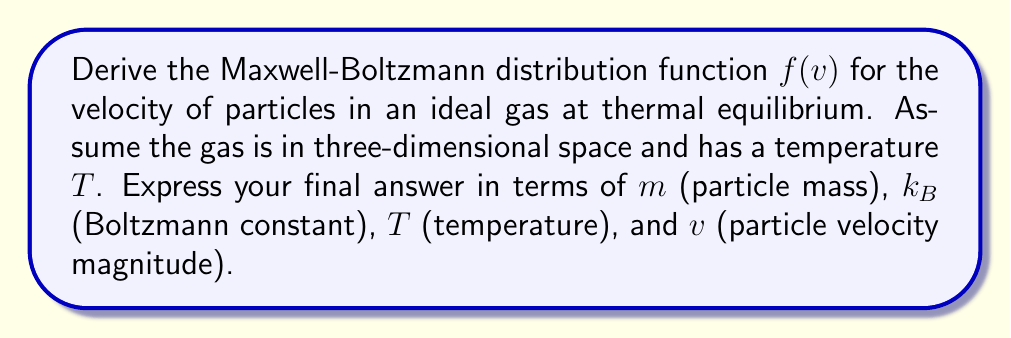Teach me how to tackle this problem. 1) We start with the Boltzmann distribution for energy:

   $$P(E) \propto e^{-E/k_BT}$$

2) For an ideal gas, the energy is purely kinetic:

   $$E = \frac{1}{2}mv^2$$

3) Substitute this into the Boltzmann distribution:

   $$P(v) \propto e^{-mv^2/2k_BT}$$

4) We need to normalize this distribution. In 3D space, the volume element is $4\pi v^2 dv$. So, the distribution function is:

   $$f(v) = Av^2e^{-mv^2/2k_BT}$$

   where $A$ is a normalization constant.

5) To find $A$, we use the condition that the integral of $f(v)$ over all velocities must equal 1:

   $$\int_0^\infty f(v) dv = 1$$

6) Solving this integral (using the substitution $u = mv^2/2k_BT$):

   $$A = 4\pi \left(\frac{m}{2\pi k_BT}\right)^{3/2}$$

7) Substituting this back into our distribution function:

   $$f(v) = 4\pi \left(\frac{m}{2\pi k_BT}\right)^{3/2} v^2 e^{-mv^2/2k_BT}$$

This is the Maxwell-Boltzmann distribution function.
Answer: $$f(v) = 4\pi \left(\frac{m}{2\pi k_BT}\right)^{3/2} v^2 e^{-mv^2/2k_BT}$$ 